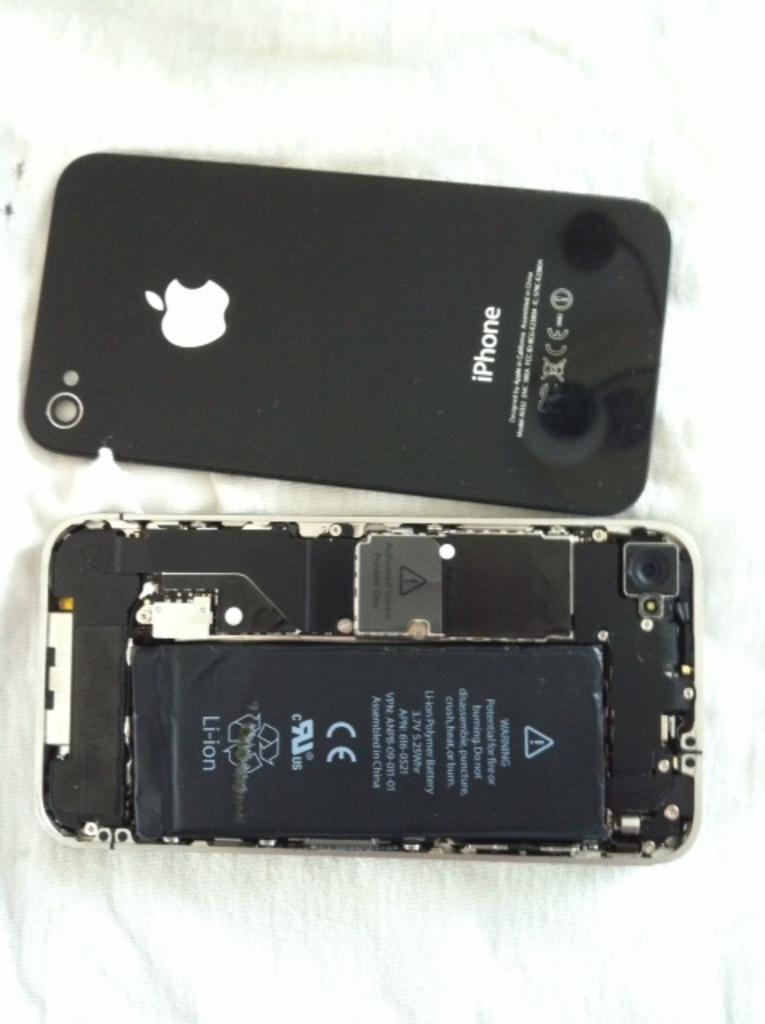<image>
Relay a brief, clear account of the picture shown. A black Iphone has been taken apart to show the battery inside 